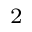<formula> <loc_0><loc_0><loc_500><loc_500>^ { 2 }</formula> 